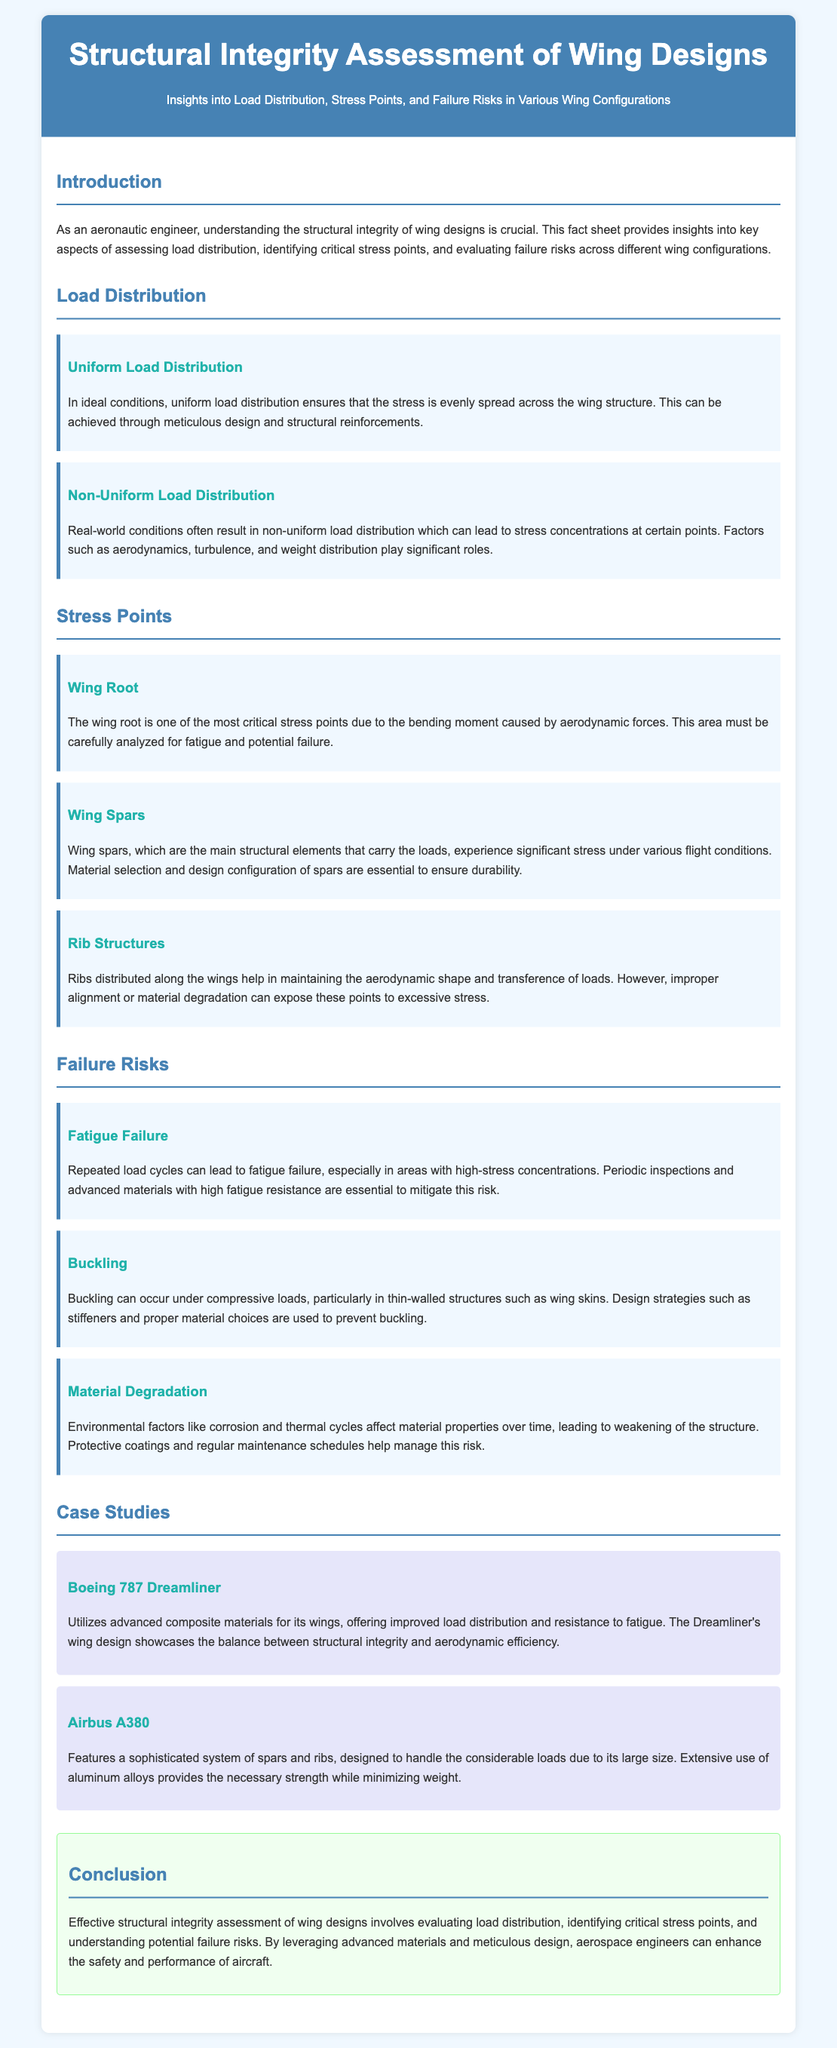What is the title of the document? The title of the document is provided in the header section.
Answer: Structural Integrity Assessment of Wing Designs What are the two types of load distribution discussed? The document mentions two types of load distributions under the Load Distribution section.
Answer: Uniform and Non-Uniform What is a critical stress point mentioned in the document? The document lists specific stress points under the Stress Points section.
Answer: Wing Root Which type of failure is associated with repeated load cycles? The document categorizes different failure risks including those caused by load cycles.
Answer: Fatigue Failure What material is primarily used in the Boeing 787 Dreamliner's wings? The case study on Boeing 787 Dreamliner states the type of materials utilized.
Answer: Composite materials What is one of the strategies mentioned to prevent buckling? The document discusses design strategies under Failure Risks related to buckling.
Answer: Stiffeners How does the Airbus A380 manage to minimize weight? The case study on the Airbus A380 describes how the aircraft handles loads while being lightweight.
Answer: Aluminum alloys What is the main focus of the conclusion section? The conclusion summarizes the key components discussed in the fact sheet.
Answer: Structural integrity assessment What is the background color of the document? The document specifies a background color for the body in the style section.
Answer: Light blue 